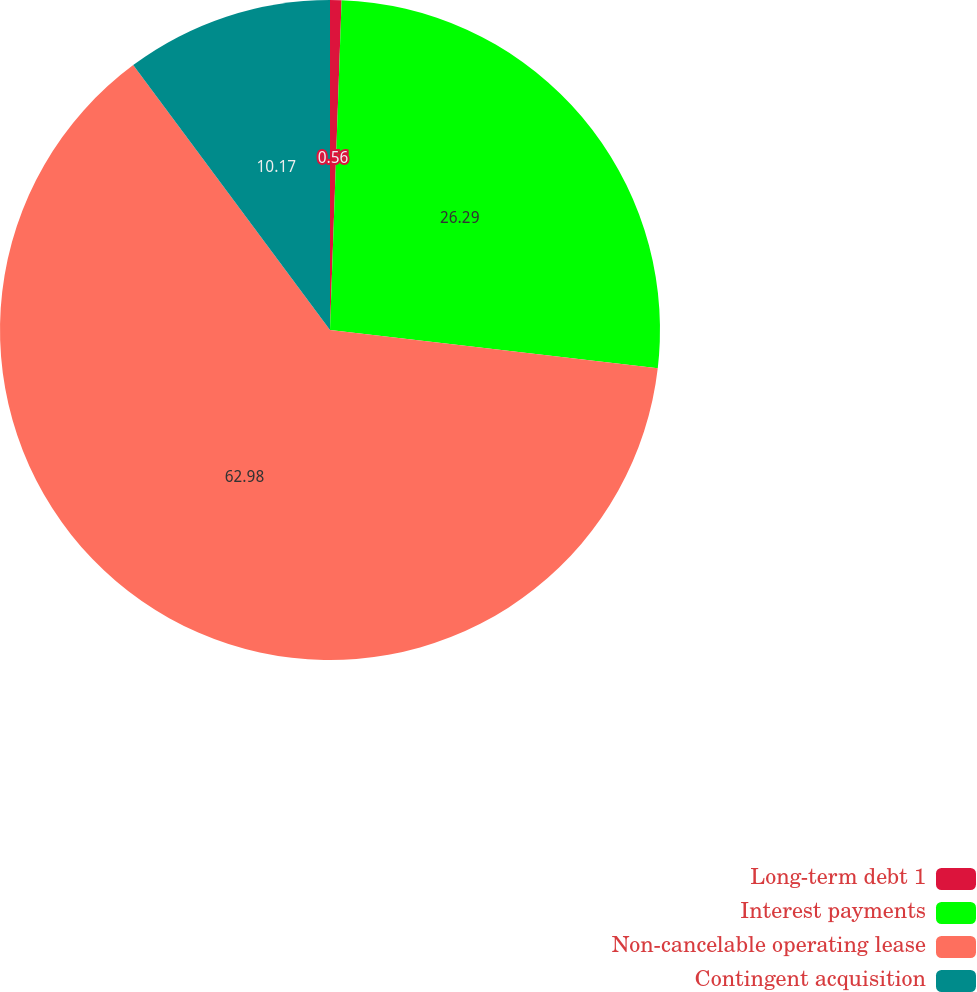Convert chart. <chart><loc_0><loc_0><loc_500><loc_500><pie_chart><fcel>Long-term debt 1<fcel>Interest payments<fcel>Non-cancelable operating lease<fcel>Contingent acquisition<nl><fcel>0.56%<fcel>26.29%<fcel>62.98%<fcel>10.17%<nl></chart> 